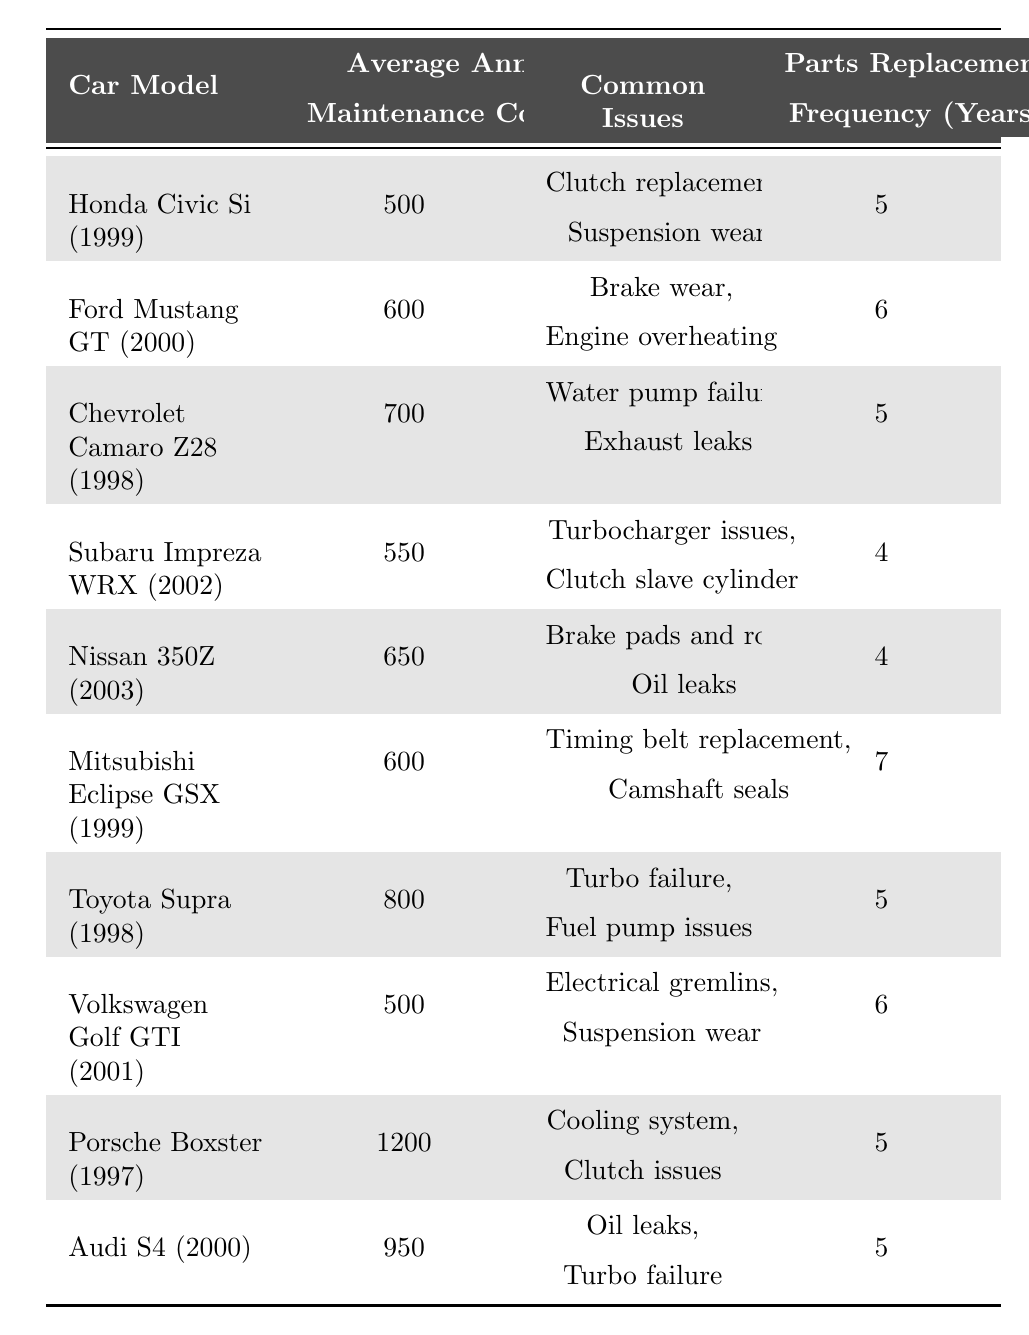What is the average annual maintenance cost of the Honda Civic Si (1999)? The table shows the average annual maintenance cost for the Honda Civic Si (1999) is listed as 500 dollars.
Answer: 500 Which car has the highest average annual maintenance cost? The table indicates that the Porsche Boxster (1997) has the highest average annual maintenance cost at 1200 dollars.
Answer: Porsche Boxster (1997) What is the parts replacement frequency for the Nissan 350Z (2003)? According to the table, the parts replacement frequency for the Nissan 350Z (2003) is 4 years.
Answer: 4 years Which cars have common issues related to suspension wear? The table lists both Honda Civic Si (1999) and Volkswagen Golf GTI (2001) as having common issues related to suspension wear.
Answer: Honda Civic Si (1999) and Volkswagen Golf GTI (2001) What is the difference in average annual maintenance cost between the Audi S4 (2000) and Ford Mustang GT (2000)? The average annual maintenance cost of the Audi S4 (2000) is 950 dollars and for the Ford Mustang GT (2000) it is 600 dollars. Calculating the difference gives us 950 - 600 = 350 dollars.
Answer: 350 Are there any cars that require parts replacement after 7 years? By reviewing the table, the Mitsubishi Eclipse GSX (1999) requires parts replacement after 7 years, which confirms that there is at least one car fitting this criteria.
Answer: Yes What is the common issue shared between the Subaru Impreza WRX (2002) and the Nissan 350Z (2003)? The common issue shared between these two cars is that both have issues related to the clutch, specifically the clutch slave cylinder for the Subaru and unspecified clutch issues for the Nissan.
Answer: Clutch-related issues On average, what is the maintenance cost for cars that have a parts replacement frequency of 5 years? The cars with a 5-year replacement frequency are the Honda Civic Si (1999), Chevrolet Camaro Z28 (1998), Toyota Supra (1998), Porsche Boxster (1997), and Audi S4 (2000). Their costs are 500, 700, 800, 1200, and 950 respectively. The total is 500 + 700 + 800 + 1200 + 950 = 4150, and the average is 4150/5 = 830 dollars.
Answer: 830 Which car has more common issues: the Ford Mustang GT (2000) or the Subaru Impreza WRX (2002)? The Ford Mustang GT (2000) has 2 common issues (brake wear and engine overheating), and the Subaru Impreza WRX (2002) also has 2 common issues (turbocharger issues and clutch slave cylinder). Therefore, both cars have the same number of common issues.
Answer: Same number of issues (2 each) Is it true that the Chevrolet Camaro Z28 (1998) has an average annual maintenance cost higher than that of the Ford Mustang GT (2000)? The average annual maintenance cost for the Chevrolet Camaro Z28 (1998) is 700 dollars while for the Ford Mustang GT (2000) it is 600 dollars, confirming that the statement is true.
Answer: True 